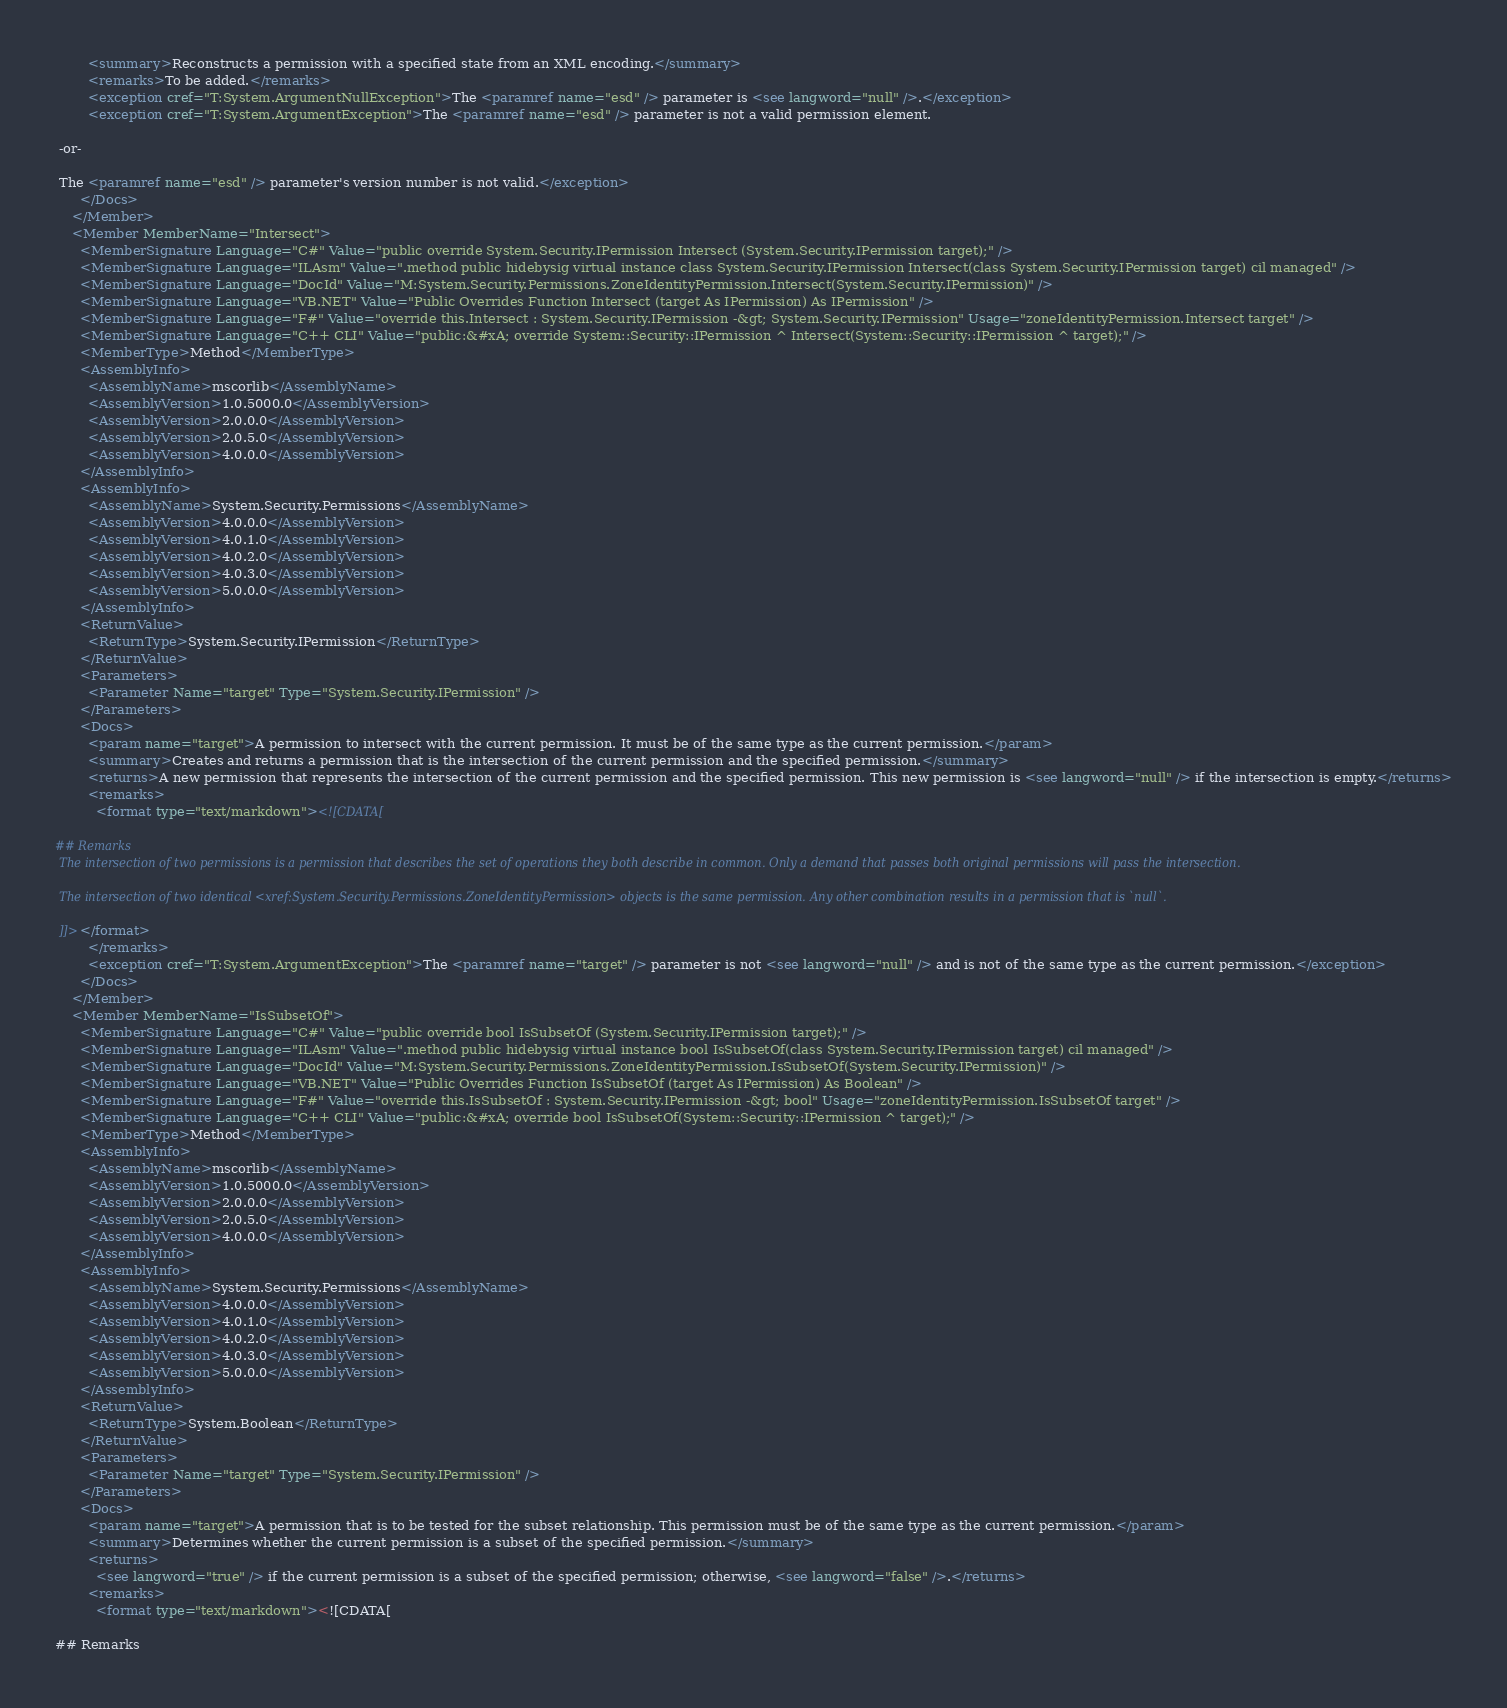<code> <loc_0><loc_0><loc_500><loc_500><_XML_>        <summary>Reconstructs a permission with a specified state from an XML encoding.</summary>
        <remarks>To be added.</remarks>
        <exception cref="T:System.ArgumentNullException">The <paramref name="esd" /> parameter is <see langword="null" />.</exception>
        <exception cref="T:System.ArgumentException">The <paramref name="esd" /> parameter is not a valid permission element.  
  
 -or-  
  
 The <paramref name="esd" /> parameter's version number is not valid.</exception>
      </Docs>
    </Member>
    <Member MemberName="Intersect">
      <MemberSignature Language="C#" Value="public override System.Security.IPermission Intersect (System.Security.IPermission target);" />
      <MemberSignature Language="ILAsm" Value=".method public hidebysig virtual instance class System.Security.IPermission Intersect(class System.Security.IPermission target) cil managed" />
      <MemberSignature Language="DocId" Value="M:System.Security.Permissions.ZoneIdentityPermission.Intersect(System.Security.IPermission)" />
      <MemberSignature Language="VB.NET" Value="Public Overrides Function Intersect (target As IPermission) As IPermission" />
      <MemberSignature Language="F#" Value="override this.Intersect : System.Security.IPermission -&gt; System.Security.IPermission" Usage="zoneIdentityPermission.Intersect target" />
      <MemberSignature Language="C++ CLI" Value="public:&#xA; override System::Security::IPermission ^ Intersect(System::Security::IPermission ^ target);" />
      <MemberType>Method</MemberType>
      <AssemblyInfo>
        <AssemblyName>mscorlib</AssemblyName>
        <AssemblyVersion>1.0.5000.0</AssemblyVersion>
        <AssemblyVersion>2.0.0.0</AssemblyVersion>
        <AssemblyVersion>2.0.5.0</AssemblyVersion>
        <AssemblyVersion>4.0.0.0</AssemblyVersion>
      </AssemblyInfo>
      <AssemblyInfo>
        <AssemblyName>System.Security.Permissions</AssemblyName>
        <AssemblyVersion>4.0.0.0</AssemblyVersion>
        <AssemblyVersion>4.0.1.0</AssemblyVersion>
        <AssemblyVersion>4.0.2.0</AssemblyVersion>
        <AssemblyVersion>4.0.3.0</AssemblyVersion>
        <AssemblyVersion>5.0.0.0</AssemblyVersion>
      </AssemblyInfo>
      <ReturnValue>
        <ReturnType>System.Security.IPermission</ReturnType>
      </ReturnValue>
      <Parameters>
        <Parameter Name="target" Type="System.Security.IPermission" />
      </Parameters>
      <Docs>
        <param name="target">A permission to intersect with the current permission. It must be of the same type as the current permission.</param>
        <summary>Creates and returns a permission that is the intersection of the current permission and the specified permission.</summary>
        <returns>A new permission that represents the intersection of the current permission and the specified permission. This new permission is <see langword="null" /> if the intersection is empty.</returns>
        <remarks>
          <format type="text/markdown"><![CDATA[  
  
## Remarks  
 The intersection of two permissions is a permission that describes the set of operations they both describe in common. Only a demand that passes both original permissions will pass the intersection.  
  
 The intersection of two identical <xref:System.Security.Permissions.ZoneIdentityPermission> objects is the same permission. Any other combination results in a permission that is `null`.  
  
 ]]></format>
        </remarks>
        <exception cref="T:System.ArgumentException">The <paramref name="target" /> parameter is not <see langword="null" /> and is not of the same type as the current permission.</exception>
      </Docs>
    </Member>
    <Member MemberName="IsSubsetOf">
      <MemberSignature Language="C#" Value="public override bool IsSubsetOf (System.Security.IPermission target);" />
      <MemberSignature Language="ILAsm" Value=".method public hidebysig virtual instance bool IsSubsetOf(class System.Security.IPermission target) cil managed" />
      <MemberSignature Language="DocId" Value="M:System.Security.Permissions.ZoneIdentityPermission.IsSubsetOf(System.Security.IPermission)" />
      <MemberSignature Language="VB.NET" Value="Public Overrides Function IsSubsetOf (target As IPermission) As Boolean" />
      <MemberSignature Language="F#" Value="override this.IsSubsetOf : System.Security.IPermission -&gt; bool" Usage="zoneIdentityPermission.IsSubsetOf target" />
      <MemberSignature Language="C++ CLI" Value="public:&#xA; override bool IsSubsetOf(System::Security::IPermission ^ target);" />
      <MemberType>Method</MemberType>
      <AssemblyInfo>
        <AssemblyName>mscorlib</AssemblyName>
        <AssemblyVersion>1.0.5000.0</AssemblyVersion>
        <AssemblyVersion>2.0.0.0</AssemblyVersion>
        <AssemblyVersion>2.0.5.0</AssemblyVersion>
        <AssemblyVersion>4.0.0.0</AssemblyVersion>
      </AssemblyInfo>
      <AssemblyInfo>
        <AssemblyName>System.Security.Permissions</AssemblyName>
        <AssemblyVersion>4.0.0.0</AssemblyVersion>
        <AssemblyVersion>4.0.1.0</AssemblyVersion>
        <AssemblyVersion>4.0.2.0</AssemblyVersion>
        <AssemblyVersion>4.0.3.0</AssemblyVersion>
        <AssemblyVersion>5.0.0.0</AssemblyVersion>
      </AssemblyInfo>
      <ReturnValue>
        <ReturnType>System.Boolean</ReturnType>
      </ReturnValue>
      <Parameters>
        <Parameter Name="target" Type="System.Security.IPermission" />
      </Parameters>
      <Docs>
        <param name="target">A permission that is to be tested for the subset relationship. This permission must be of the same type as the current permission.</param>
        <summary>Determines whether the current permission is a subset of the specified permission.</summary>
        <returns>
          <see langword="true" /> if the current permission is a subset of the specified permission; otherwise, <see langword="false" />.</returns>
        <remarks>
          <format type="text/markdown"><![CDATA[  
  
## Remarks  </code> 